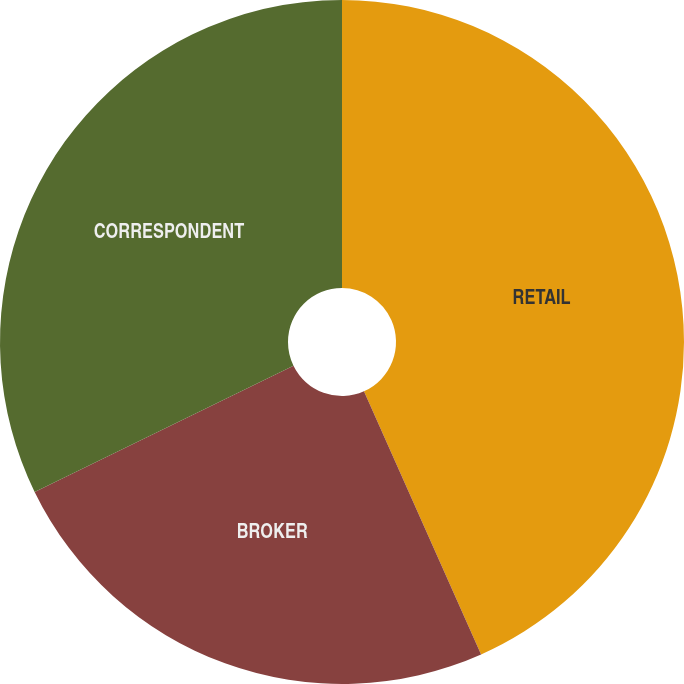<chart> <loc_0><loc_0><loc_500><loc_500><pie_chart><fcel>RETAIL<fcel>BROKER<fcel>CORRESPONDENT<nl><fcel>43.33%<fcel>24.44%<fcel>32.22%<nl></chart> 